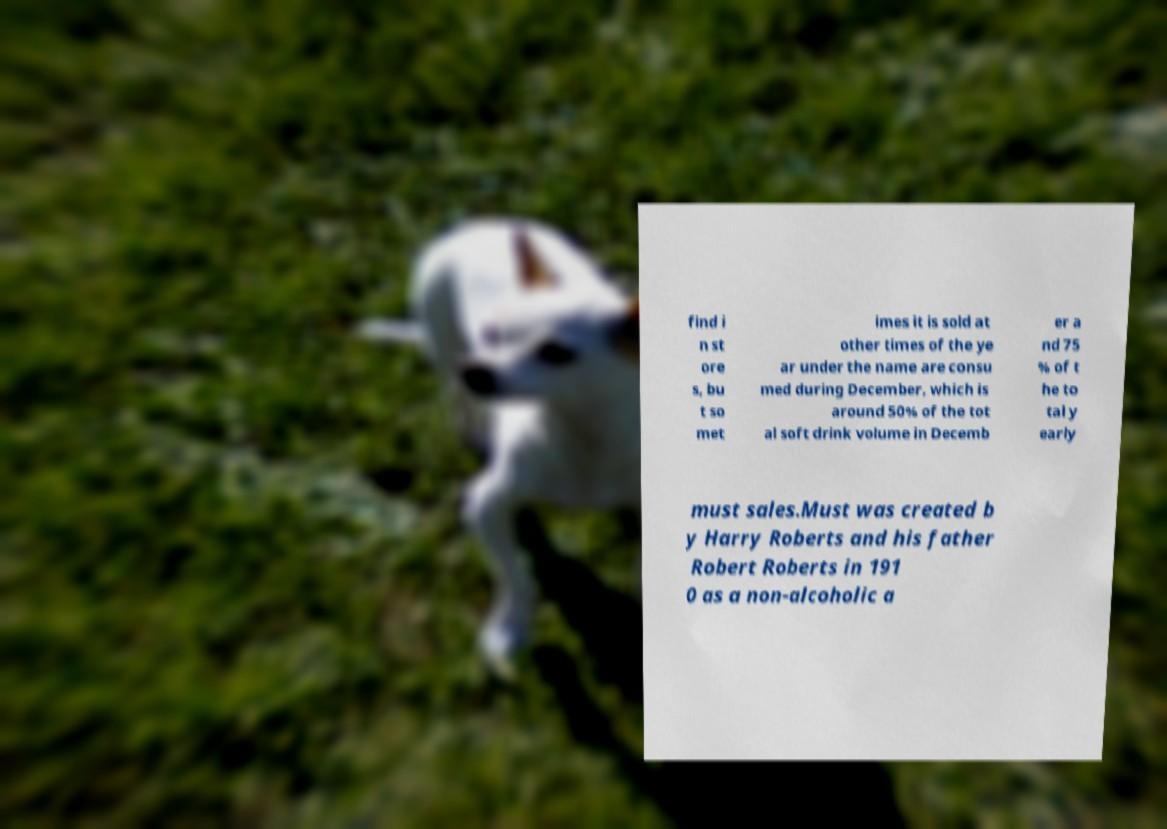Please identify and transcribe the text found in this image. find i n st ore s, bu t so met imes it is sold at other times of the ye ar under the name are consu med during December, which is around 50% of the tot al soft drink volume in Decemb er a nd 75 % of t he to tal y early must sales.Must was created b y Harry Roberts and his father Robert Roberts in 191 0 as a non-alcoholic a 